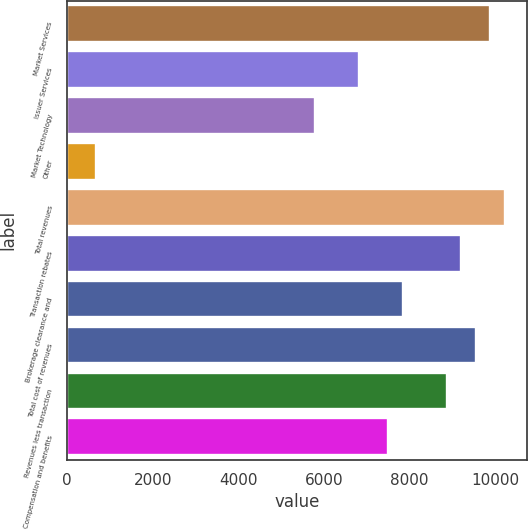<chart> <loc_0><loc_0><loc_500><loc_500><bar_chart><fcel>Market Services<fcel>Issuer Services<fcel>Market Technology<fcel>Other<fcel>Total revenues<fcel>Transaction rebates<fcel>Brokerage clearance and<fcel>Total cost of revenues<fcel>Revenues less transaction<fcel>Compensation and benefits<nl><fcel>9889.64<fcel>6820.83<fcel>5797.89<fcel>683.21<fcel>10230.6<fcel>9207.68<fcel>7843.77<fcel>9548.66<fcel>8866.7<fcel>7502.79<nl></chart> 